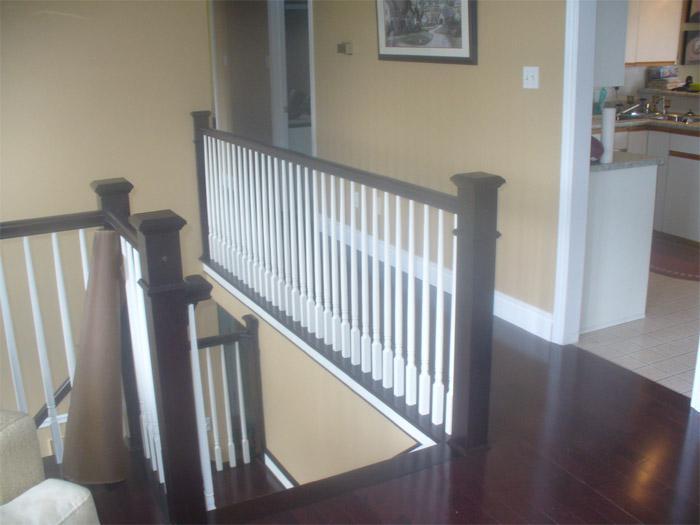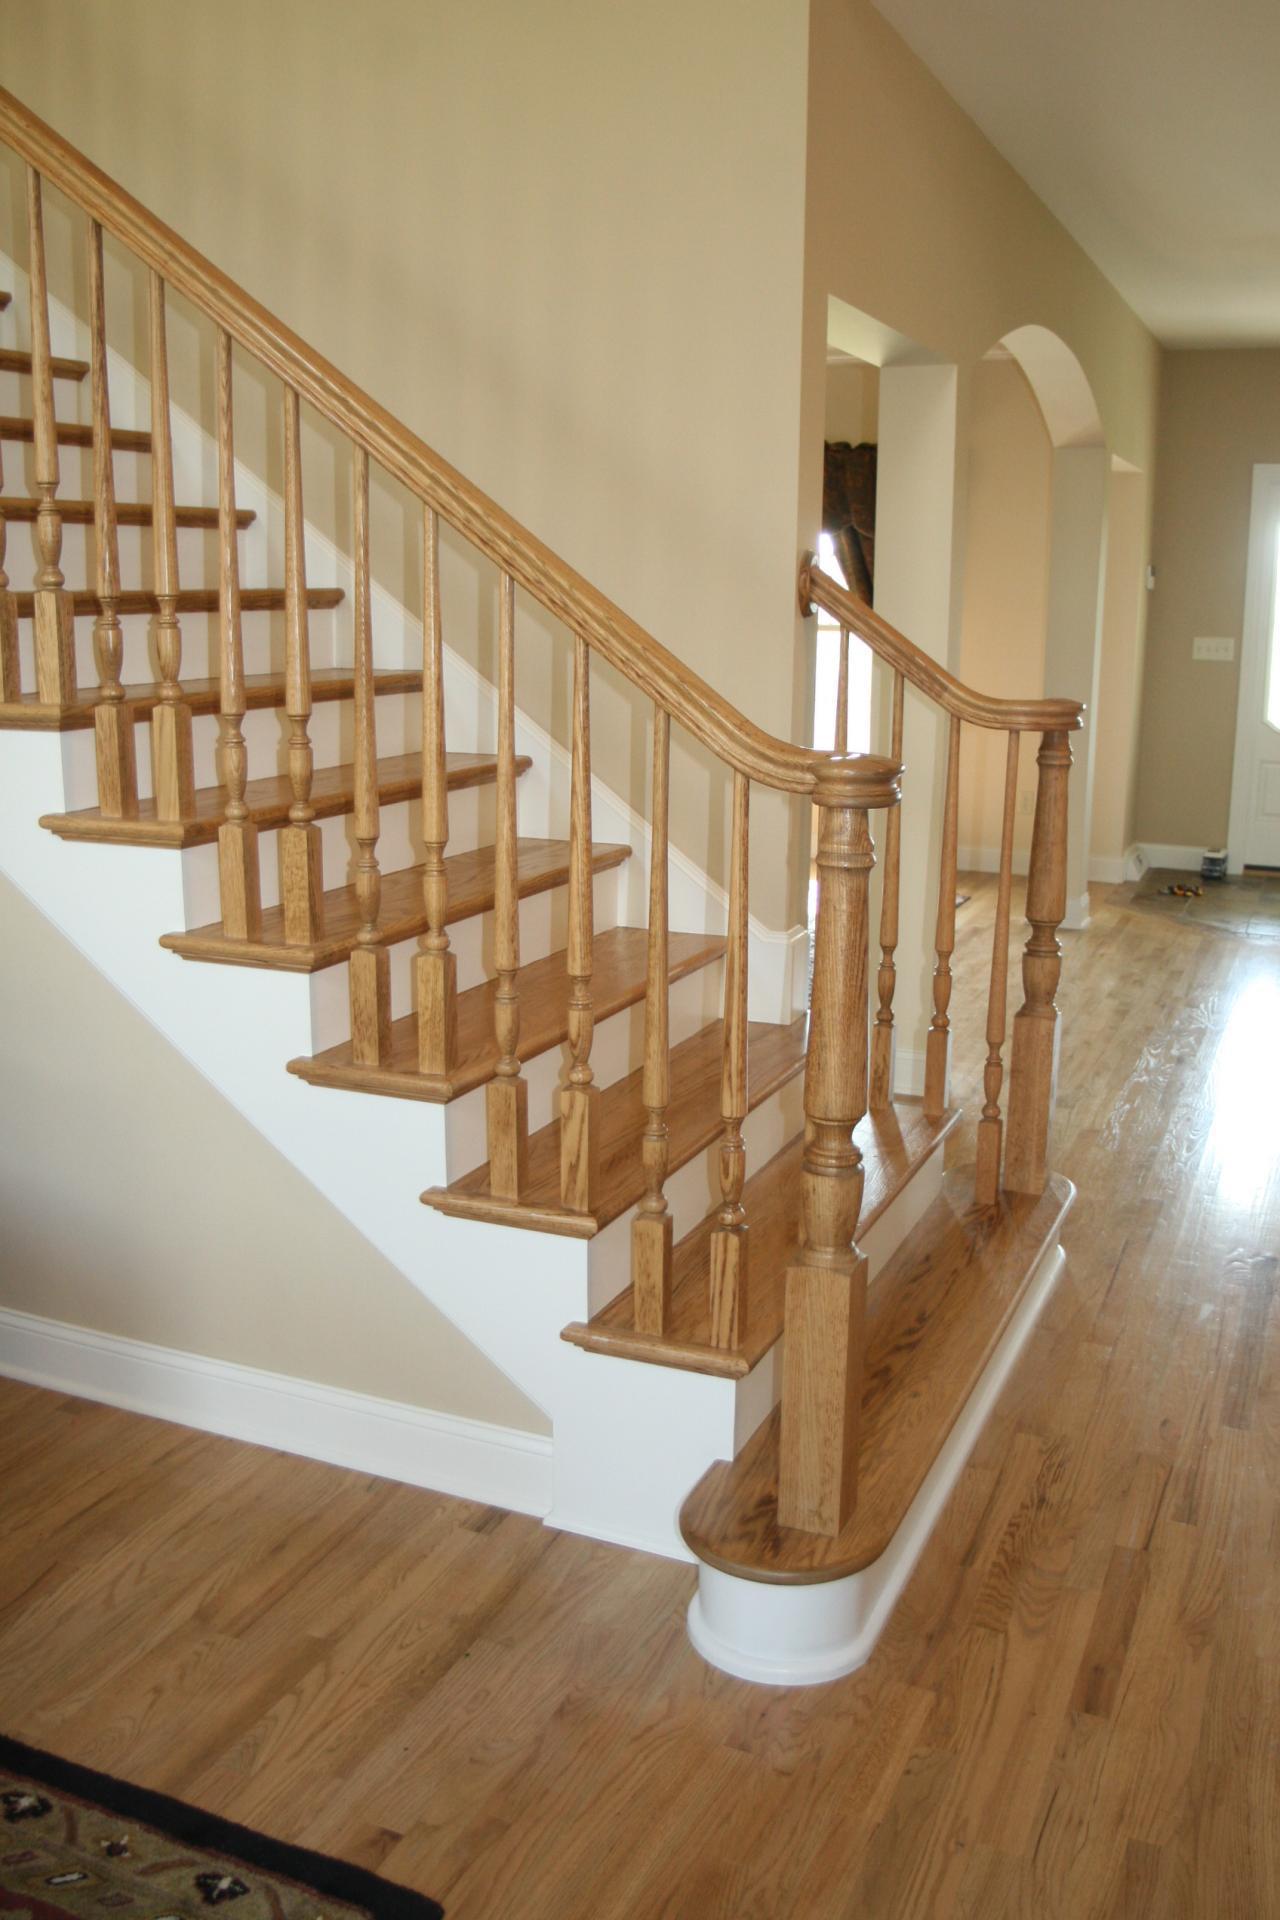The first image is the image on the left, the second image is the image on the right. For the images displayed, is the sentence "In one image, at least one newel post is at the bottom of stairs, but in the second image, two newel posts are at the top of stairs." factually correct? Answer yes or no. Yes. The first image is the image on the left, the second image is the image on the right. Considering the images on both sides, is "there is a srairway being shown from the top floor, the rails are white and the top rail is painted black" valid? Answer yes or no. Yes. 